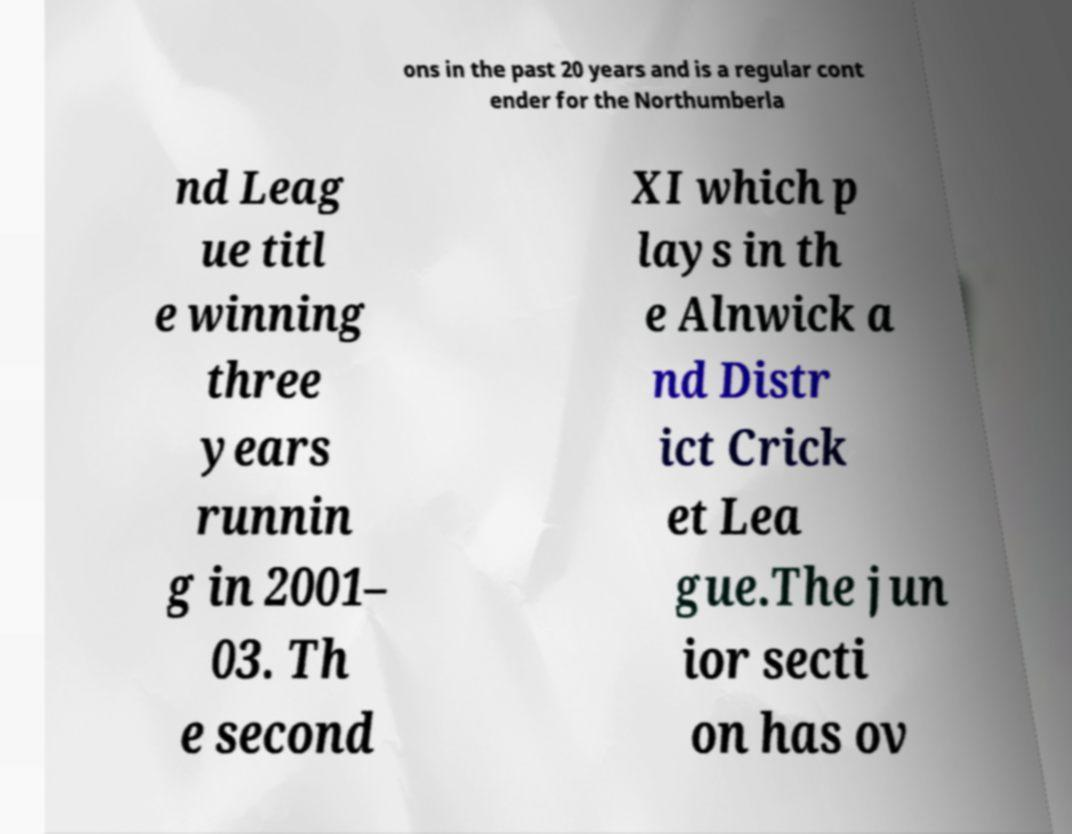Please identify and transcribe the text found in this image. ons in the past 20 years and is a regular cont ender for the Northumberla nd Leag ue titl e winning three years runnin g in 2001– 03. Th e second XI which p lays in th e Alnwick a nd Distr ict Crick et Lea gue.The jun ior secti on has ov 